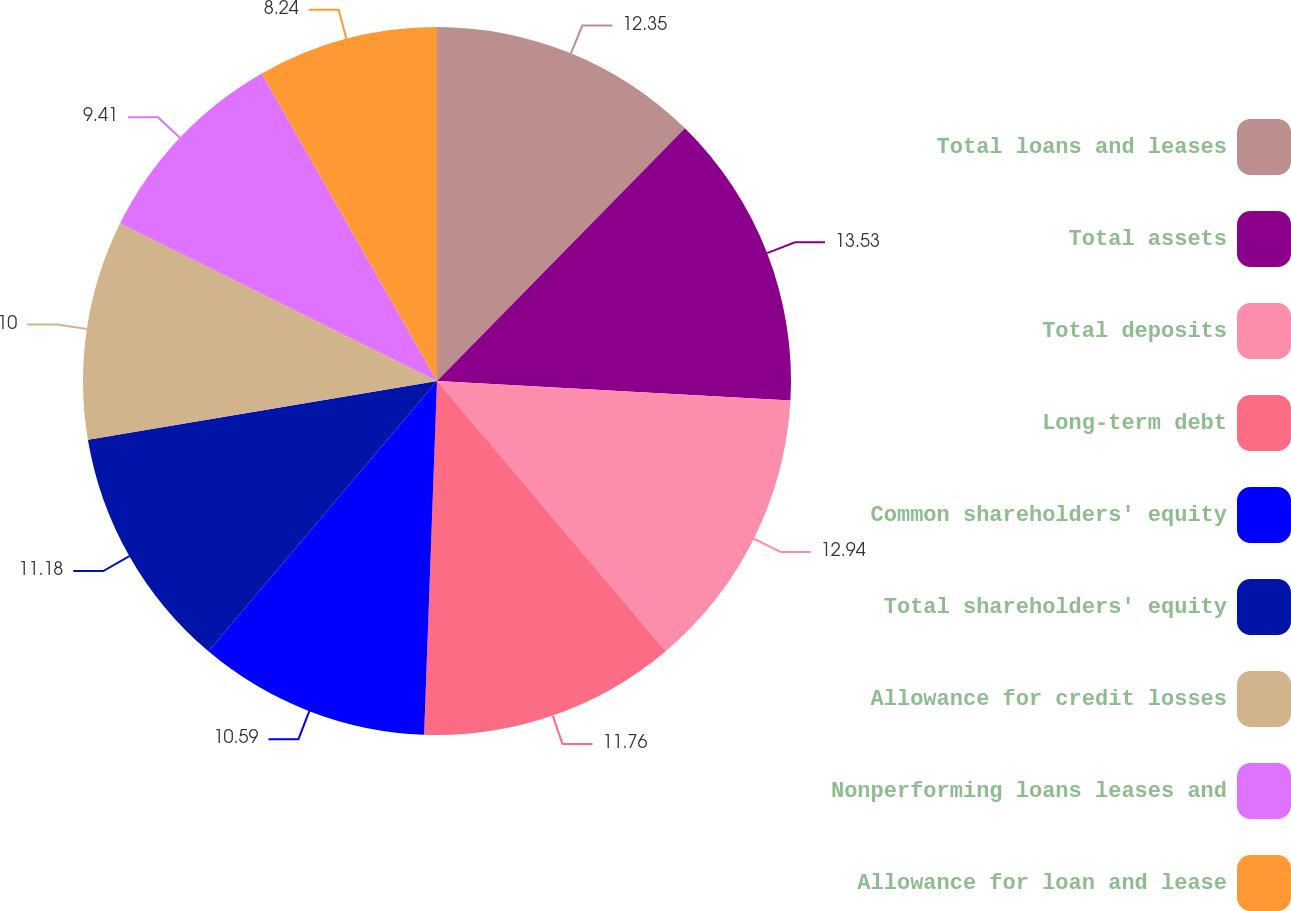Convert chart to OTSL. <chart><loc_0><loc_0><loc_500><loc_500><pie_chart><fcel>Total loans and leases<fcel>Total assets<fcel>Total deposits<fcel>Long-term debt<fcel>Common shareholders' equity<fcel>Total shareholders' equity<fcel>Allowance for credit losses<fcel>Nonperforming loans leases and<fcel>Allowance for loan and lease<nl><fcel>12.35%<fcel>13.53%<fcel>12.94%<fcel>11.76%<fcel>10.59%<fcel>11.18%<fcel>10.0%<fcel>9.41%<fcel>8.24%<nl></chart> 